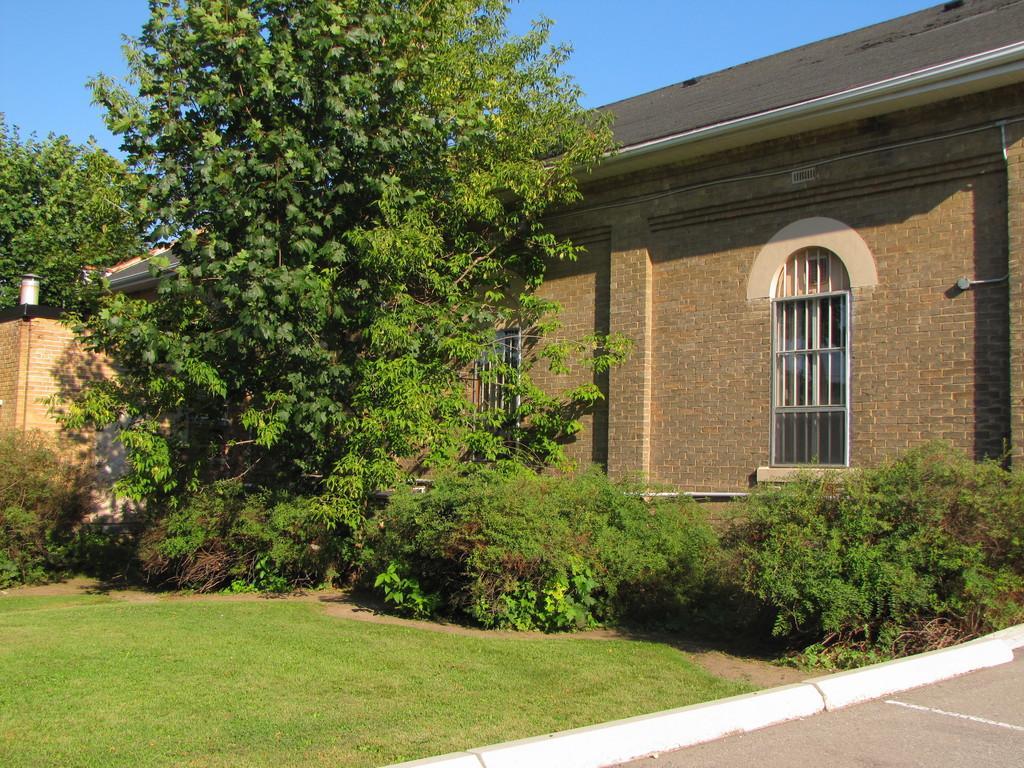Could you give a brief overview of what you see in this image? In this image we can see there is a house and there is a light attached to the wall. And there are trees, grass and the sky. 